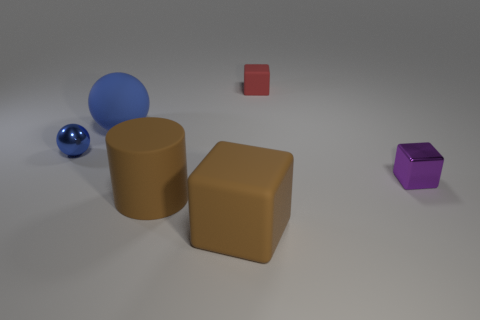There is a cube that is in front of the purple shiny block; is there a blue rubber thing that is in front of it?
Ensure brevity in your answer.  No. How big is the blue rubber sphere?
Ensure brevity in your answer.  Large. The tiny thing that is both in front of the red block and right of the tiny blue thing has what shape?
Your answer should be compact. Cube. What number of red objects are either rubber things or cubes?
Offer a very short reply. 1. There is a metal cube on the right side of the large cylinder; is it the same size as the cube that is in front of the purple block?
Keep it short and to the point. No. How many things are small blue objects or big brown rubber cubes?
Offer a terse response. 2. Are there any other blue things of the same shape as the blue rubber thing?
Provide a short and direct response. Yes. Are there fewer tiny yellow shiny cylinders than metal things?
Your answer should be compact. Yes. Is the blue matte thing the same shape as the small blue object?
Make the answer very short. Yes. How many objects are either big purple matte cylinders or brown matte things left of the big brown rubber block?
Give a very brief answer. 1. 